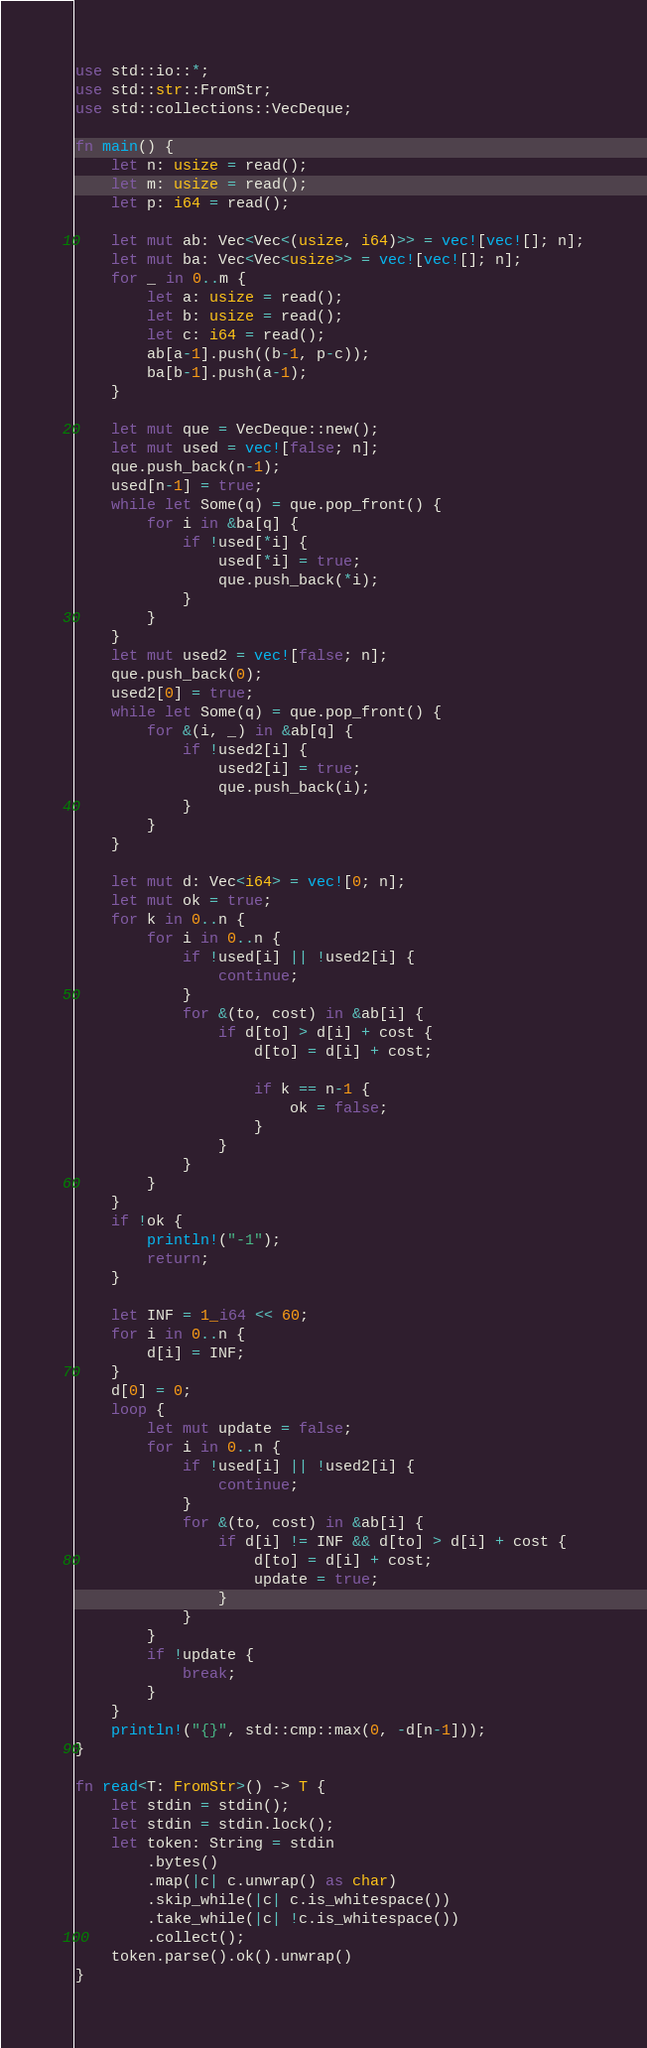Convert code to text. <code><loc_0><loc_0><loc_500><loc_500><_Rust_>use std::io::*;
use std::str::FromStr;
use std::collections::VecDeque;

fn main() {
    let n: usize = read();
    let m: usize = read();
    let p: i64 = read();

    let mut ab: Vec<Vec<(usize, i64)>> = vec![vec![]; n];
    let mut ba: Vec<Vec<usize>> = vec![vec![]; n];
    for _ in 0..m {
        let a: usize = read();
        let b: usize = read();
        let c: i64 = read();
        ab[a-1].push((b-1, p-c));
        ba[b-1].push(a-1);
    }

    let mut que = VecDeque::new();
    let mut used = vec![false; n];
    que.push_back(n-1);
    used[n-1] = true;
    while let Some(q) = que.pop_front() {
        for i in &ba[q] {
            if !used[*i] {
                used[*i] = true;
                que.push_back(*i);
            }
        }
    }
    let mut used2 = vec![false; n];
    que.push_back(0);
    used2[0] = true;
    while let Some(q) = que.pop_front() {
        for &(i, _) in &ab[q] {
            if !used2[i] {
                used2[i] = true;
                que.push_back(i);
            }
        }
    }

    let mut d: Vec<i64> = vec![0; n];
    let mut ok = true;
    for k in 0..n {
        for i in 0..n {
            if !used[i] || !used2[i] {
                continue;
            }
            for &(to, cost) in &ab[i] {
                if d[to] > d[i] + cost {
                    d[to] = d[i] + cost;

                    if k == n-1 {
                        ok = false;
                    }
                }
            }
        }
    }
    if !ok {
        println!("-1");
        return;
    }

    let INF = 1_i64 << 60;
    for i in 0..n {
        d[i] = INF;
    }
    d[0] = 0;
    loop {
        let mut update = false;
        for i in 0..n {
            if !used[i] || !used2[i] {
                continue;
            }
            for &(to, cost) in &ab[i] {
                if d[i] != INF && d[to] > d[i] + cost {
                    d[to] = d[i] + cost;
                    update = true;
                }
            }
        }
        if !update {
            break;
        }
    }
    println!("{}", std::cmp::max(0, -d[n-1]));
}

fn read<T: FromStr>() -> T {
    let stdin = stdin();
    let stdin = stdin.lock();
    let token: String = stdin
        .bytes()
        .map(|c| c.unwrap() as char)
        .skip_while(|c| c.is_whitespace())
        .take_while(|c| !c.is_whitespace())
        .collect();
    token.parse().ok().unwrap()
}
</code> 